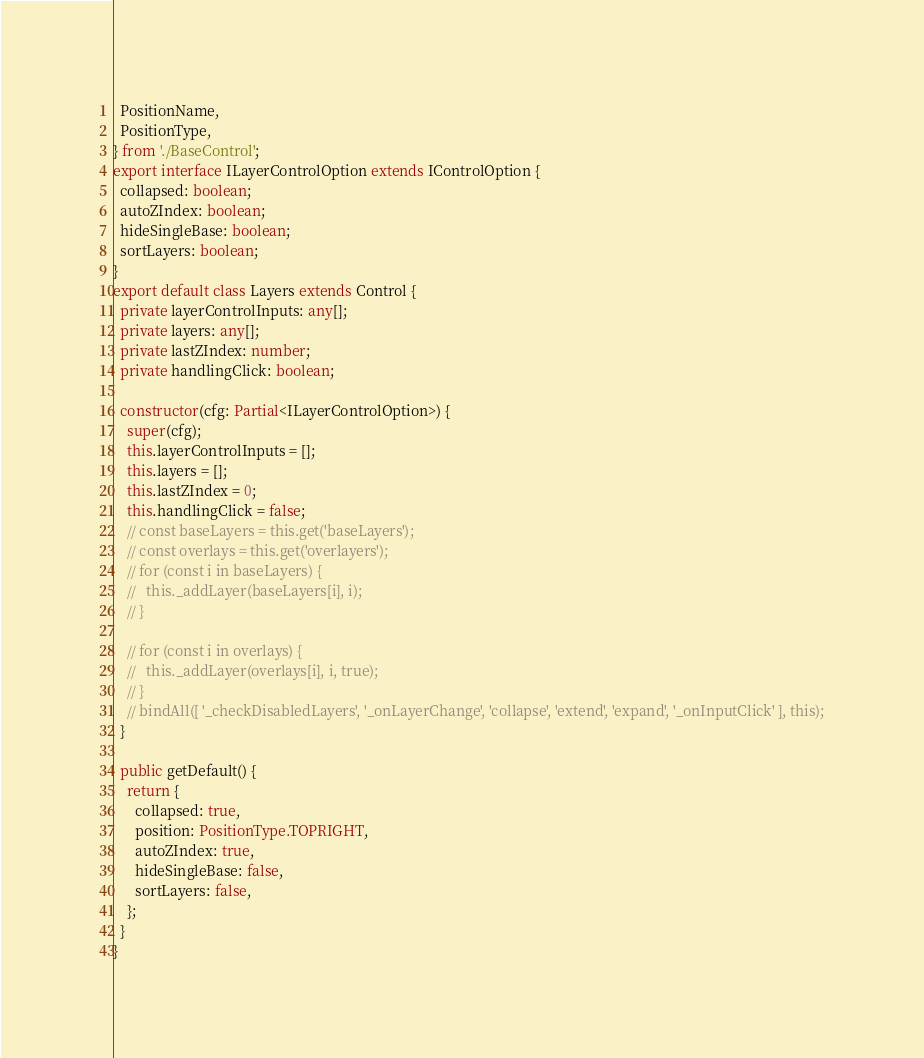<code> <loc_0><loc_0><loc_500><loc_500><_TypeScript_>  PositionName,
  PositionType,
} from './BaseControl';
export interface ILayerControlOption extends IControlOption {
  collapsed: boolean;
  autoZIndex: boolean;
  hideSingleBase: boolean;
  sortLayers: boolean;
}
export default class Layers extends Control {
  private layerControlInputs: any[];
  private layers: any[];
  private lastZIndex: number;
  private handlingClick: boolean;

  constructor(cfg: Partial<ILayerControlOption>) {
    super(cfg);
    this.layerControlInputs = [];
    this.layers = [];
    this.lastZIndex = 0;
    this.handlingClick = false;
    // const baseLayers = this.get('baseLayers');
    // const overlays = this.get('overlayers');
    // for (const i in baseLayers) {
    //   this._addLayer(baseLayers[i], i);
    // }

    // for (const i in overlays) {
    //   this._addLayer(overlays[i], i, true);
    // }
    // bindAll([ '_checkDisabledLayers', '_onLayerChange', 'collapse', 'extend', 'expand', '_onInputClick' ], this);
  }

  public getDefault() {
    return {
      collapsed: true,
      position: PositionType.TOPRIGHT,
      autoZIndex: true,
      hideSingleBase: false,
      sortLayers: false,
    };
  }
}
</code> 